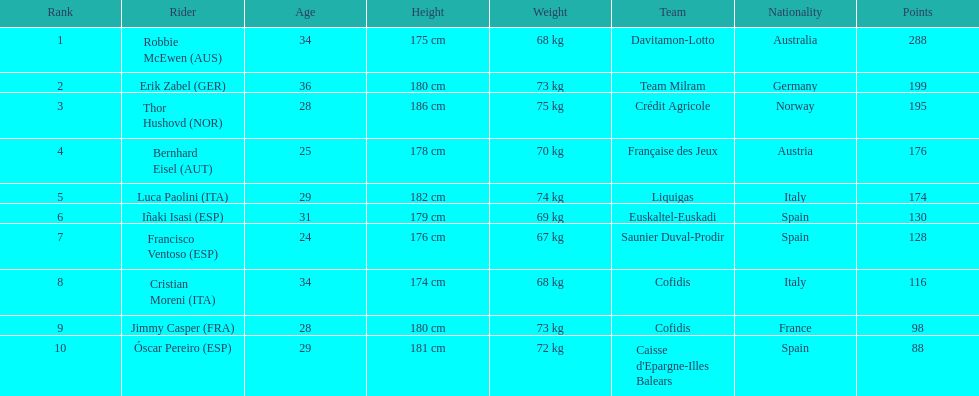How many more points did erik zabel score than franciso ventoso? 71. 